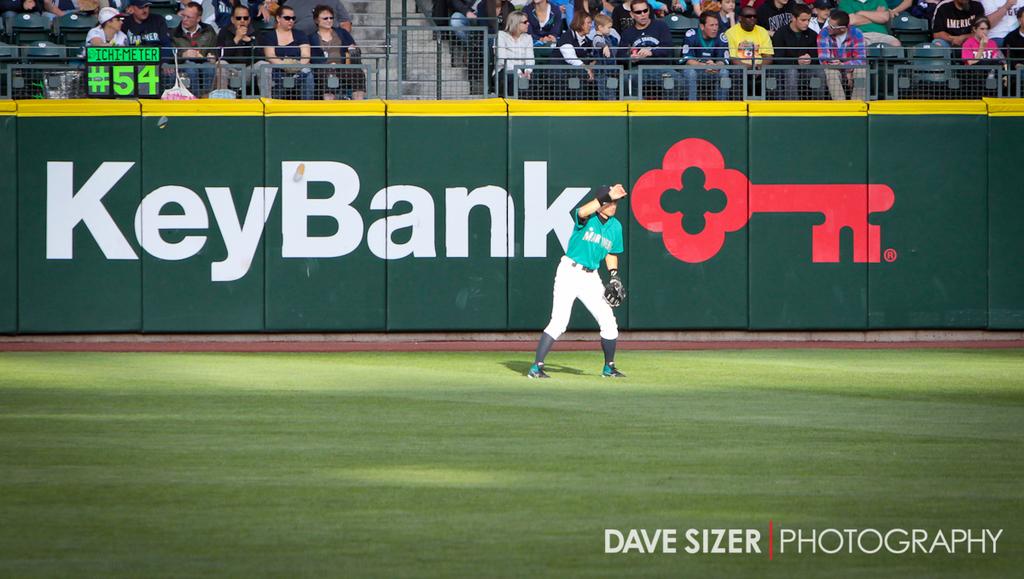What is the name of the bank?
Your answer should be compact. Keybank. 